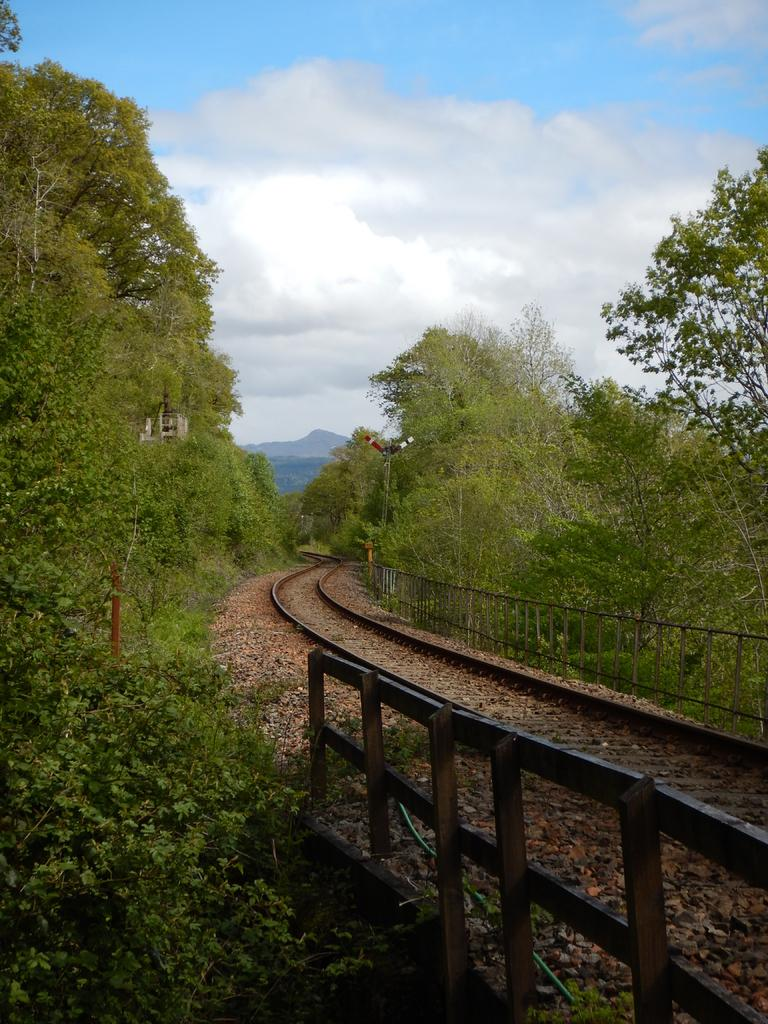What type of transportation infrastructure is visible in the image? There is a train track in the image. What safety feature can be seen in the image? There is a railing in the image. What type of vegetation is present on both sides of the image? There are trees on the right side and the left side of the image. What geographical feature is visible in the background of the image? There is a mountain in the background of the image. What is the condition of the sky in the image? The sky is clear in the image. Can you hear the powder laughing in the image? There is no powder or laughter present in the image; it only features a train track, railing, trees, a mountain, and a clear sky. 